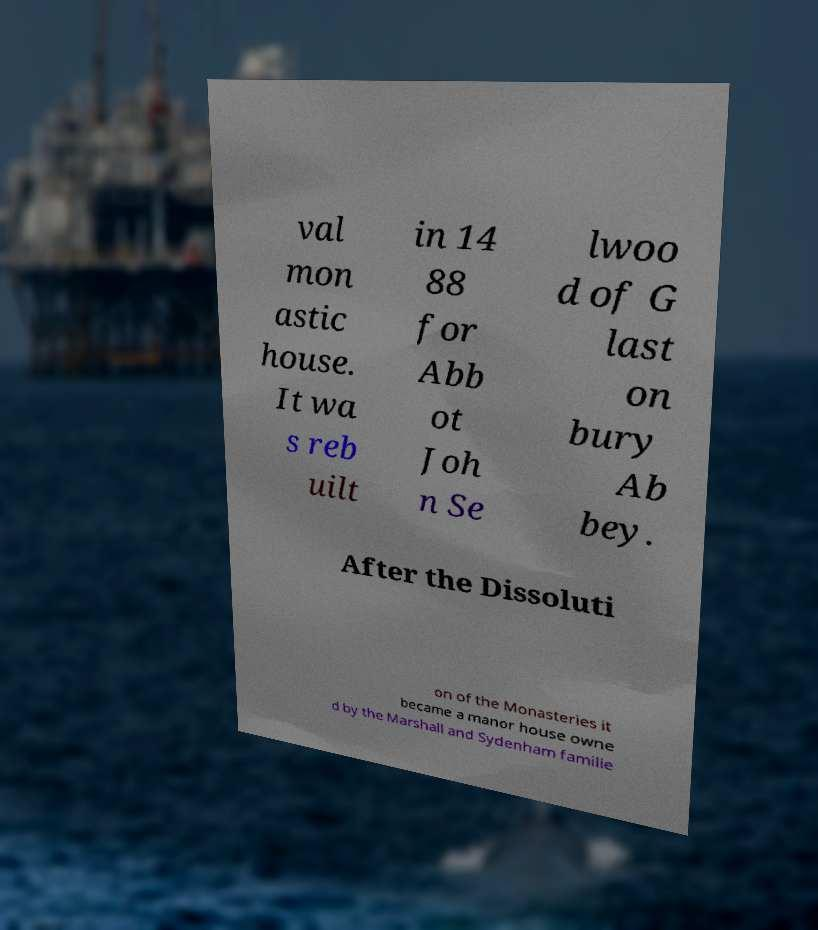I need the written content from this picture converted into text. Can you do that? val mon astic house. It wa s reb uilt in 14 88 for Abb ot Joh n Se lwoo d of G last on bury Ab bey. After the Dissoluti on of the Monasteries it became a manor house owne d by the Marshall and Sydenham familie 